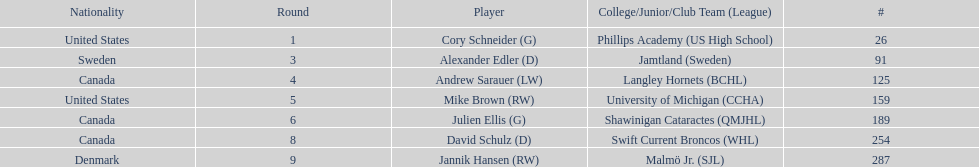List only the american players. Cory Schneider (G), Mike Brown (RW). Parse the full table. {'header': ['Nationality', 'Round', 'Player', 'College/Junior/Club Team (League)', '#'], 'rows': [['United States', '1', 'Cory Schneider (G)', 'Phillips Academy (US High School)', '26'], ['Sweden', '3', 'Alexander Edler (D)', 'Jamtland (Sweden)', '91'], ['Canada', '4', 'Andrew Sarauer (LW)', 'Langley Hornets (BCHL)', '125'], ['United States', '5', 'Mike Brown (RW)', 'University of Michigan (CCHA)', '159'], ['Canada', '6', 'Julien Ellis (G)', 'Shawinigan Cataractes (QMJHL)', '189'], ['Canada', '8', 'David Schulz (D)', 'Swift Current Broncos (WHL)', '254'], ['Denmark', '9', 'Jannik Hansen (RW)', 'Malmö Jr. (SJL)', '287']]} 